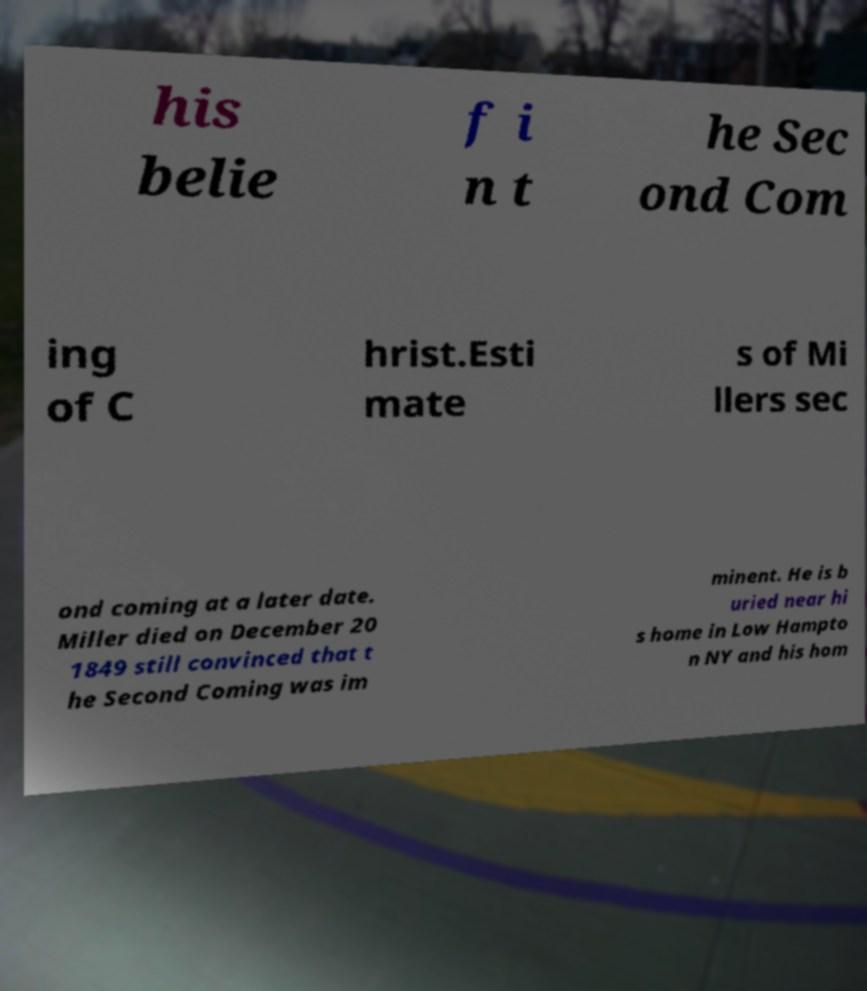For documentation purposes, I need the text within this image transcribed. Could you provide that? his belie f i n t he Sec ond Com ing of C hrist.Esti mate s of Mi llers sec ond coming at a later date. Miller died on December 20 1849 still convinced that t he Second Coming was im minent. He is b uried near hi s home in Low Hampto n NY and his hom 